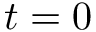<formula> <loc_0><loc_0><loc_500><loc_500>t = 0</formula> 